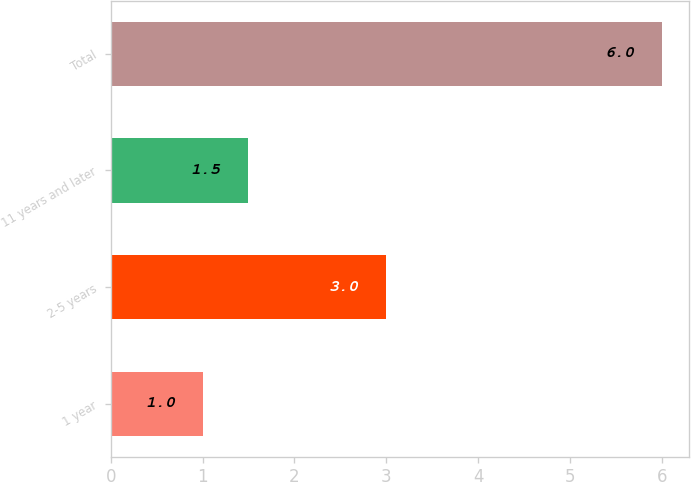Convert chart. <chart><loc_0><loc_0><loc_500><loc_500><bar_chart><fcel>1 year<fcel>2-5 years<fcel>11 years and later<fcel>Total<nl><fcel>1<fcel>3<fcel>1.5<fcel>6<nl></chart> 